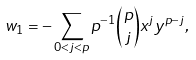Convert formula to latex. <formula><loc_0><loc_0><loc_500><loc_500>w _ { 1 } = - \sum _ { 0 < j < p } p ^ { - 1 } \binom { p } { j } x ^ { j } y ^ { p - j } ,</formula> 